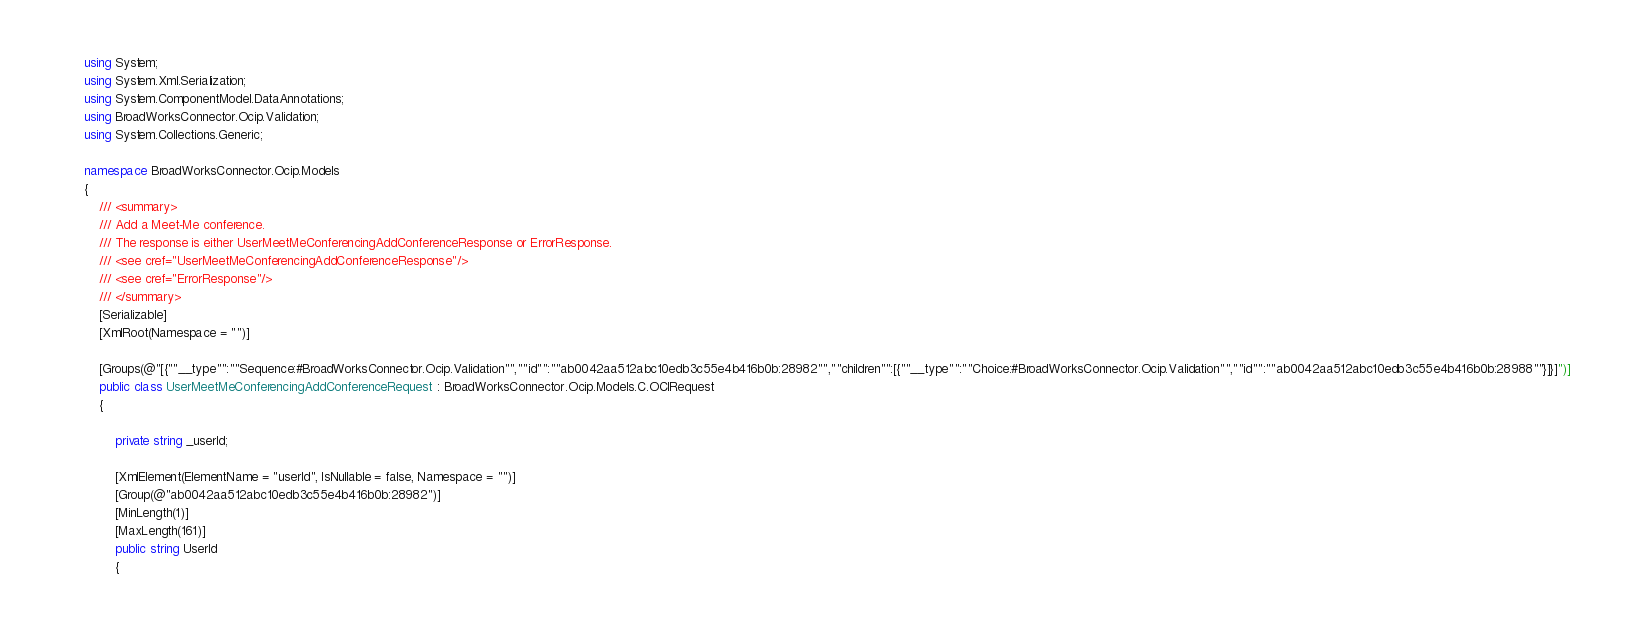<code> <loc_0><loc_0><loc_500><loc_500><_C#_>using System;
using System.Xml.Serialization;
using System.ComponentModel.DataAnnotations;
using BroadWorksConnector.Ocip.Validation;
using System.Collections.Generic;

namespace BroadWorksConnector.Ocip.Models
{
    /// <summary>
    /// Add a Meet-Me conference.
    /// The response is either UserMeetMeConferencingAddConferenceResponse or ErrorResponse.
    /// <see cref="UserMeetMeConferencingAddConferenceResponse"/>
    /// <see cref="ErrorResponse"/>
    /// </summary>
    [Serializable]
    [XmlRoot(Namespace = "")]

    [Groups(@"[{""__type"":""Sequence:#BroadWorksConnector.Ocip.Validation"",""id"":""ab0042aa512abc10edb3c55e4b416b0b:28982"",""children"":[{""__type"":""Choice:#BroadWorksConnector.Ocip.Validation"",""id"":""ab0042aa512abc10edb3c55e4b416b0b:28988""}]}]")]
    public class UserMeetMeConferencingAddConferenceRequest : BroadWorksConnector.Ocip.Models.C.OCIRequest
    {

        private string _userId;

        [XmlElement(ElementName = "userId", IsNullable = false, Namespace = "")]
        [Group(@"ab0042aa512abc10edb3c55e4b416b0b:28982")]
        [MinLength(1)]
        [MaxLength(161)]
        public string UserId
        {</code> 